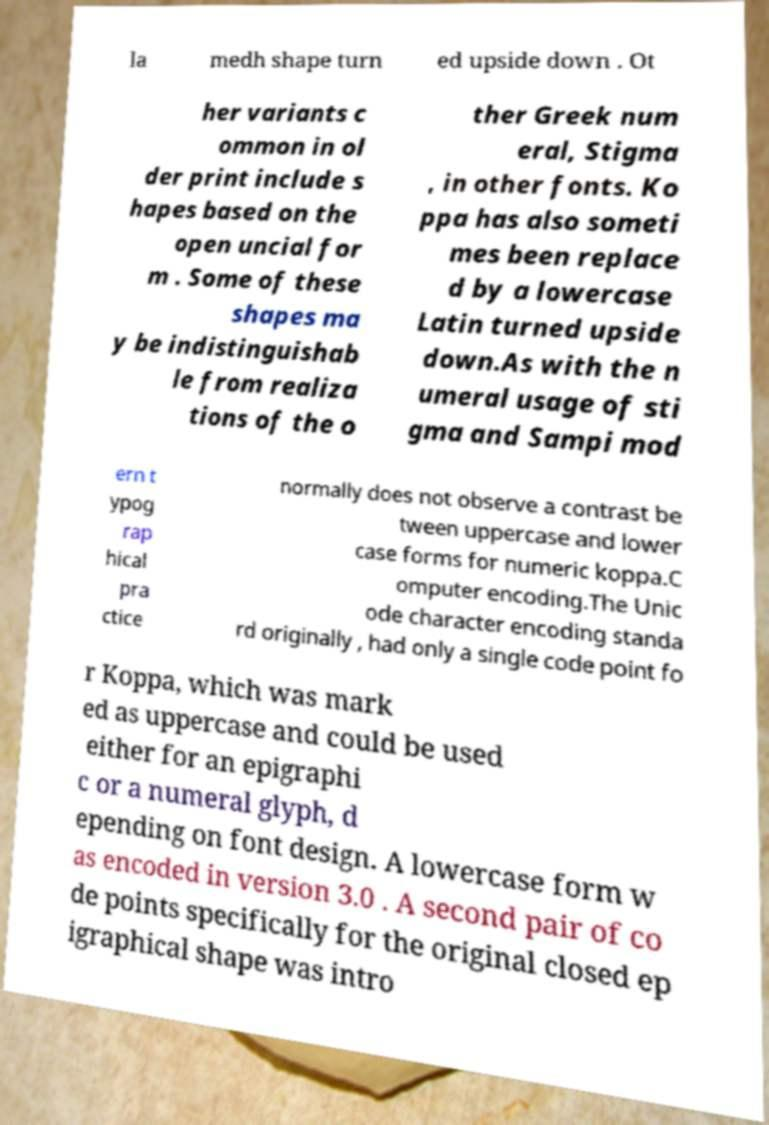What messages or text are displayed in this image? I need them in a readable, typed format. la medh shape turn ed upside down . Ot her variants c ommon in ol der print include s hapes based on the open uncial for m . Some of these shapes ma y be indistinguishab le from realiza tions of the o ther Greek num eral, Stigma , in other fonts. Ko ppa has also someti mes been replace d by a lowercase Latin turned upside down.As with the n umeral usage of sti gma and Sampi mod ern t ypog rap hical pra ctice normally does not observe a contrast be tween uppercase and lower case forms for numeric koppa.C omputer encoding.The Unic ode character encoding standa rd originally , had only a single code point fo r Koppa, which was mark ed as uppercase and could be used either for an epigraphi c or a numeral glyph, d epending on font design. A lowercase form w as encoded in version 3.0 . A second pair of co de points specifically for the original closed ep igraphical shape was intro 